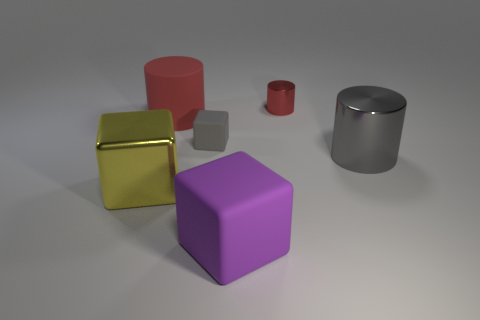Is there any other thing that has the same size as the red rubber cylinder?
Offer a terse response. Yes. How big is the gray object that is left of the big object that is in front of the yellow metallic block?
Your response must be concise. Small. There is a purple thing that is the same size as the yellow shiny thing; what is its material?
Provide a succinct answer. Rubber. Is there a large brown cylinder that has the same material as the big red object?
Provide a succinct answer. No. The rubber cube on the left side of the large rubber object in front of the metal object in front of the gray metallic thing is what color?
Provide a succinct answer. Gray. Does the cube in front of the yellow object have the same color as the metallic thing behind the small matte object?
Ensure brevity in your answer.  No. Is there any other thing that is the same color as the large shiny cylinder?
Offer a very short reply. Yes. Are there fewer small matte objects on the right side of the large gray shiny cylinder than big gray metal cubes?
Make the answer very short. No. What number of tiny red metallic cylinders are there?
Provide a short and direct response. 1. Do the big purple object and the shiny object behind the big gray metallic cylinder have the same shape?
Offer a very short reply. No. 